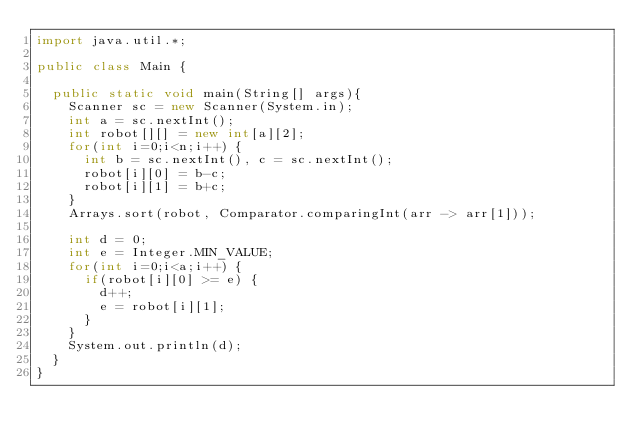<code> <loc_0><loc_0><loc_500><loc_500><_Java_>import java.util.*;
 
public class Main {
 
	public static void main(String[] args){
		Scanner sc = new Scanner(System.in);				
		int a = sc.nextInt();		
		int robot[][] = new int[a][2];		
		for(int i=0;i<n;i++) {
			int b = sc.nextInt(), c = sc.nextInt();
			robot[i][0] = b-c;
			robot[i][1] = b+c;
		}		
		Arrays.sort(robot, Comparator.comparingInt(arr -> arr[1]));
		
		int d = 0;
		int e = Integer.MIN_VALUE;
		for(int i=0;i<a;i++) {
			if(robot[i][0] >= e) {
				d++;
				e = robot[i][1];
			}
		}		
		System.out.println(d);				
	} 
}
</code> 